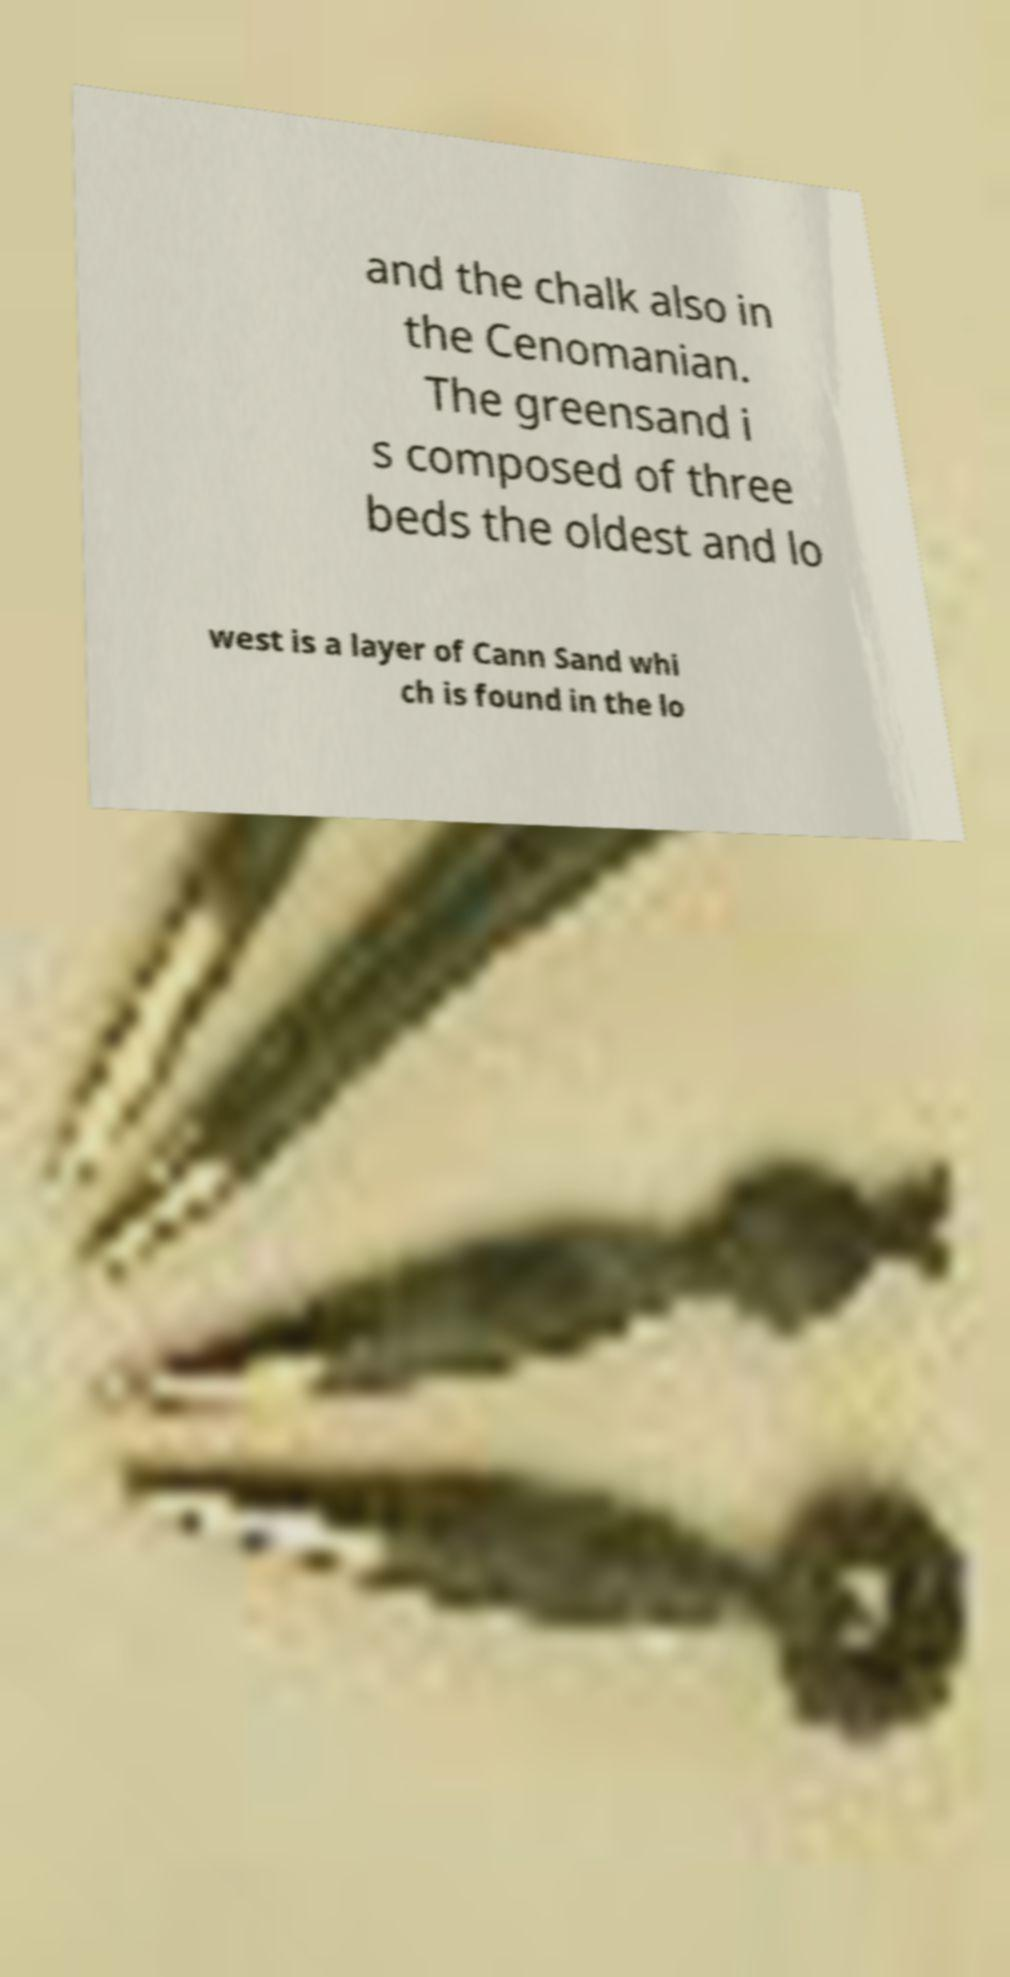Can you read and provide the text displayed in the image?This photo seems to have some interesting text. Can you extract and type it out for me? and the chalk also in the Cenomanian. The greensand i s composed of three beds the oldest and lo west is a layer of Cann Sand whi ch is found in the lo 